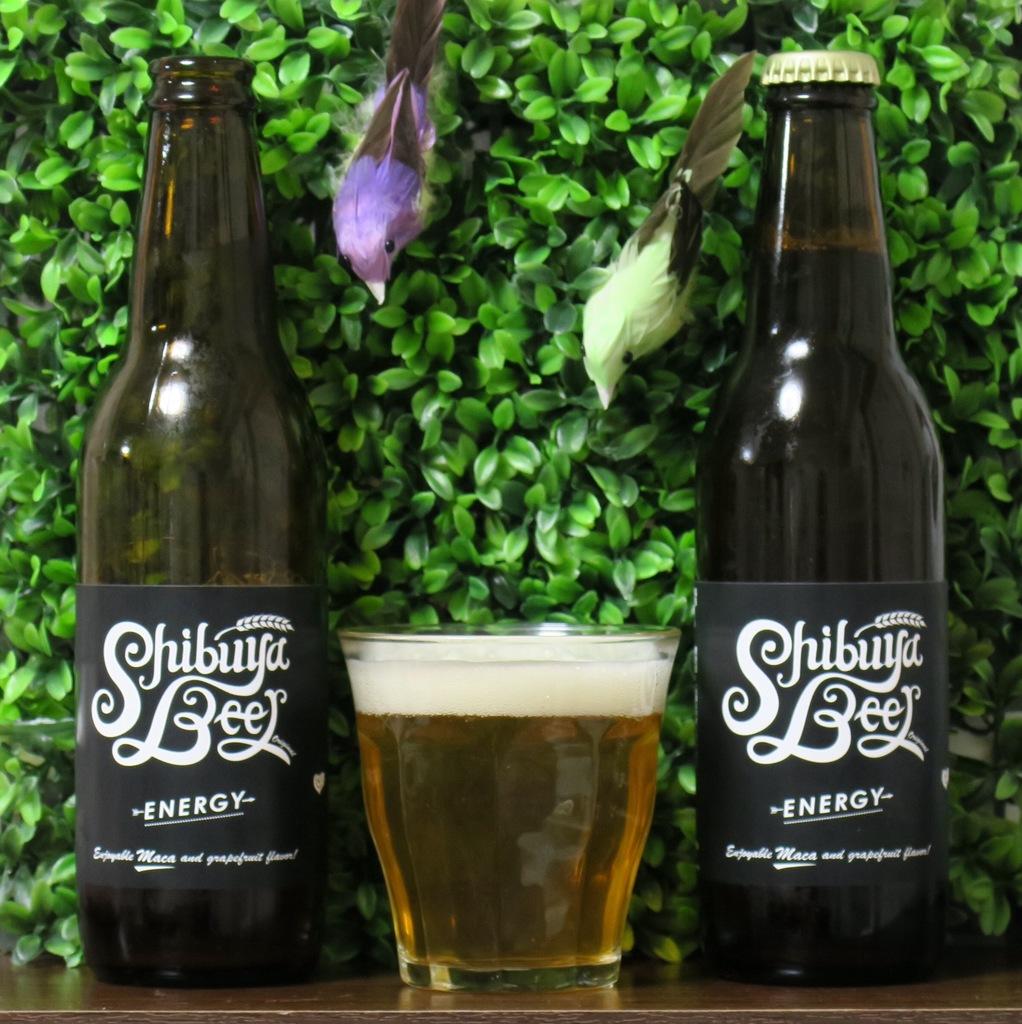What kind of beer is this?
Give a very brief answer. Shibuya beer. What word is printed under "shibuya beer" on this label?
Keep it short and to the point. Energy. 